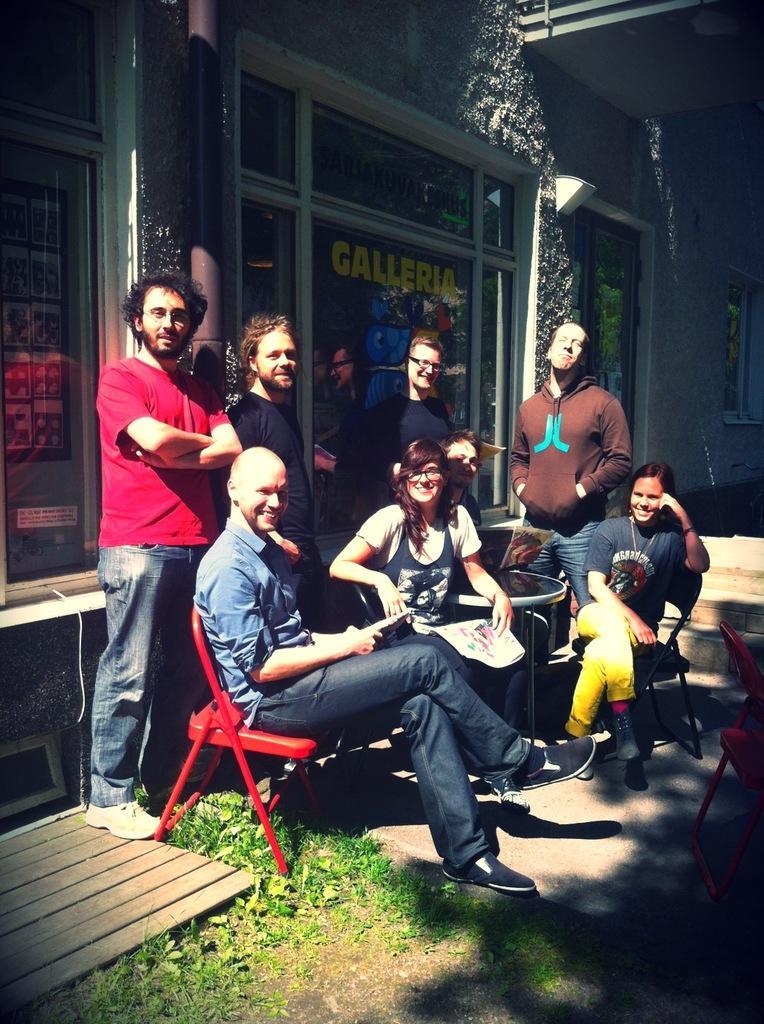Could you give a brief overview of what you see in this image? In this picture I can see group of people, there are chairs and a table, and in the background there is a building. 